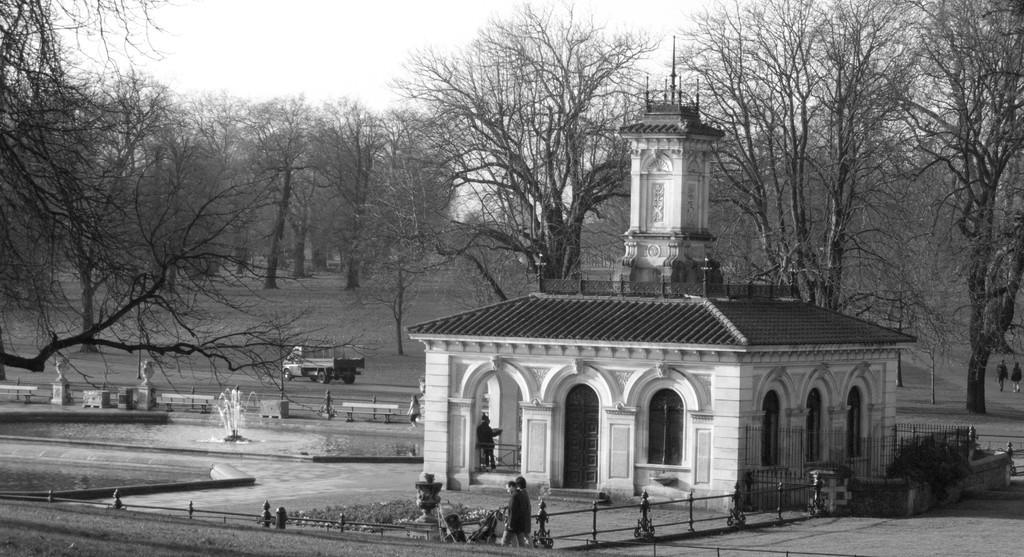In one or two sentences, can you explain what this image depicts? In this image there is sky, there are treeś, there is a vehicle, there is road, there is fountain, there is a buildings, there are personś, there are plants. 